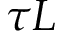<formula> <loc_0><loc_0><loc_500><loc_500>\tau L</formula> 